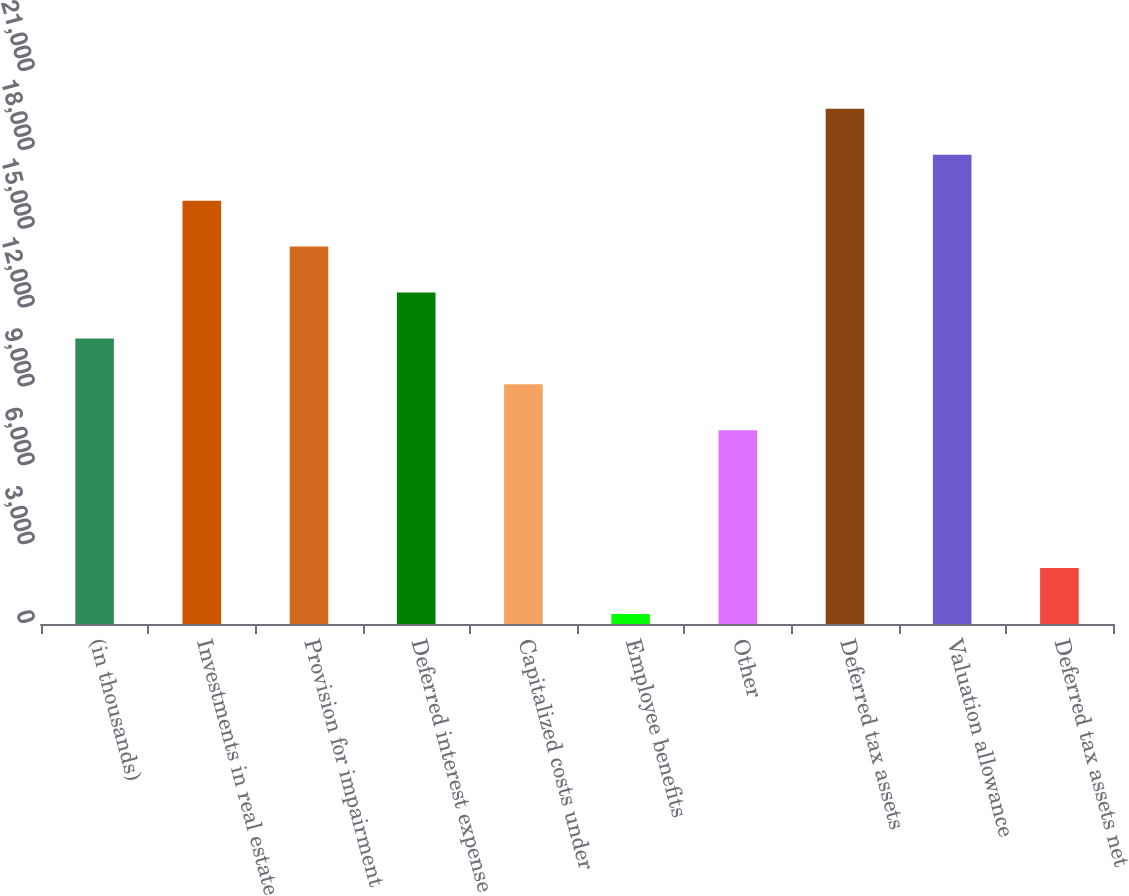Convert chart to OTSL. <chart><loc_0><loc_0><loc_500><loc_500><bar_chart><fcel>(in thousands)<fcel>Investments in real estate<fcel>Provision for impairment<fcel>Deferred interest expense<fcel>Capitalized costs under<fcel>Employee benefits<fcel>Other<fcel>Deferred tax assets<fcel>Valuation allowance<fcel>Deferred tax assets net<nl><fcel>10864.6<fcel>16104.4<fcel>14357.8<fcel>12611.2<fcel>9118<fcel>385<fcel>7371.4<fcel>19597.6<fcel>17851<fcel>2131.6<nl></chart> 